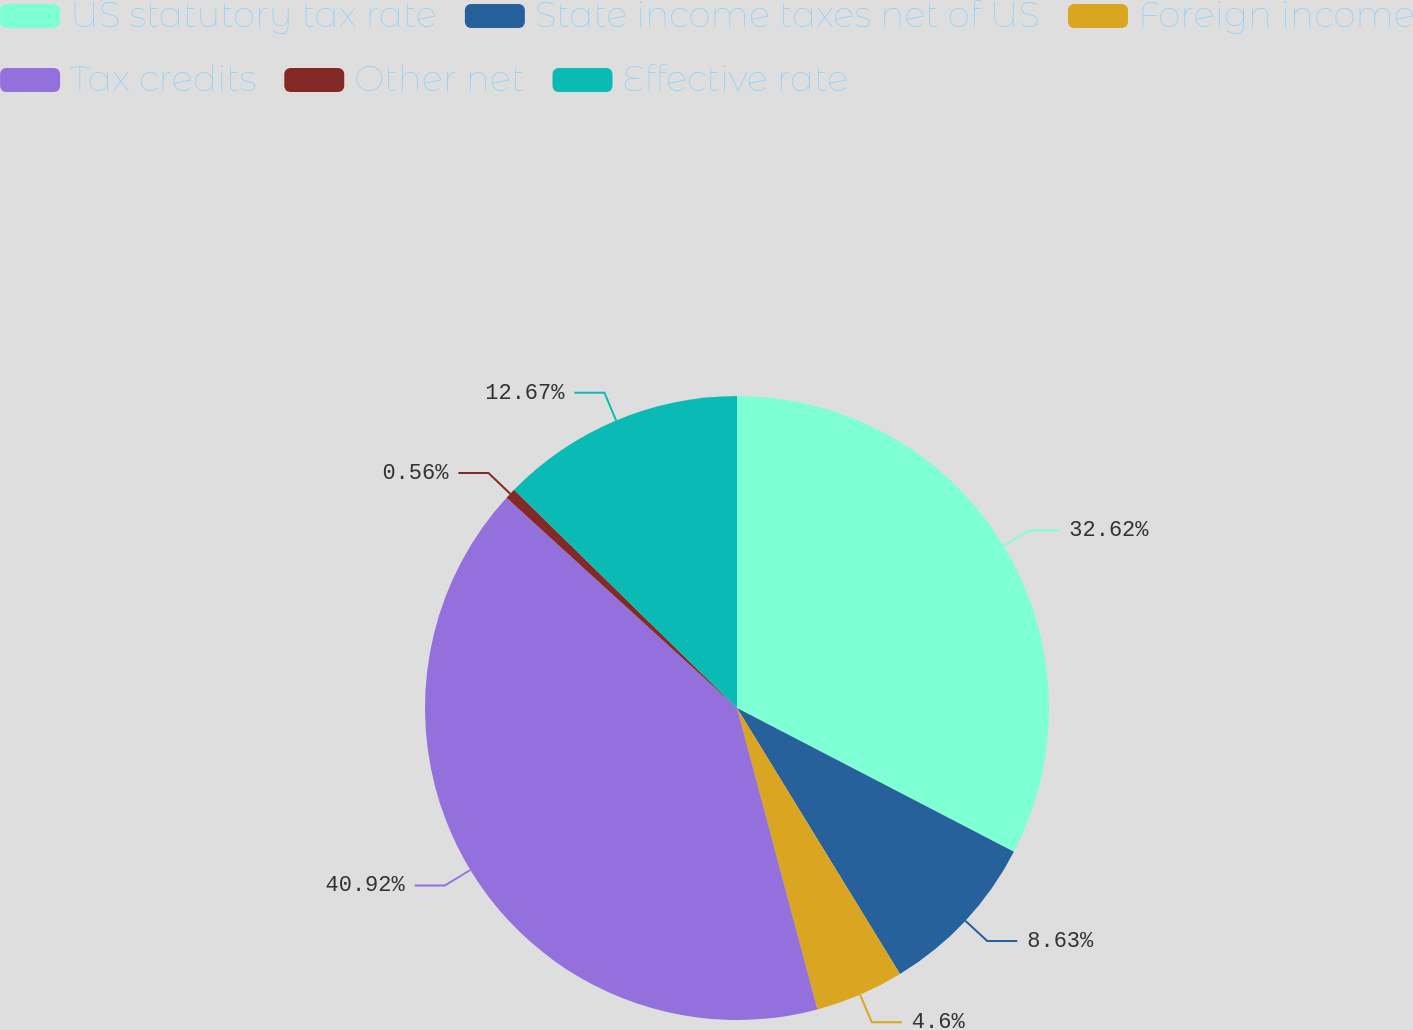Convert chart to OTSL. <chart><loc_0><loc_0><loc_500><loc_500><pie_chart><fcel>US statutory tax rate<fcel>State income taxes net of US<fcel>Foreign income<fcel>Tax credits<fcel>Other net<fcel>Effective rate<nl><fcel>32.62%<fcel>8.63%<fcel>4.6%<fcel>40.92%<fcel>0.56%<fcel>12.67%<nl></chart> 